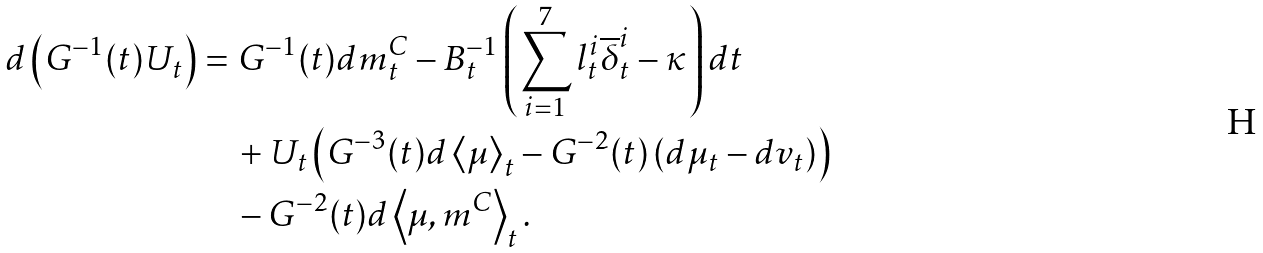<formula> <loc_0><loc_0><loc_500><loc_500>d \left ( G ^ { - 1 } ( t ) U _ { t } \right ) & = G ^ { - 1 } ( t ) d m _ { t } ^ { C } - B _ { t } ^ { - 1 } \left ( \sum _ { i = 1 } ^ { 7 } l _ { t } ^ { i } \overline { \delta } _ { t } ^ { i } - \kappa \right ) d t \\ & \quad + U _ { t } \left ( G ^ { - 3 } ( t ) d \left \langle \mu \right \rangle _ { t } - G ^ { - 2 } ( t ) \left ( d \mu _ { t } - d v _ { t } \right ) \right ) \\ & \quad - G ^ { - 2 } ( t ) d \left \langle \mu , m ^ { C } \right \rangle _ { t } .</formula> 